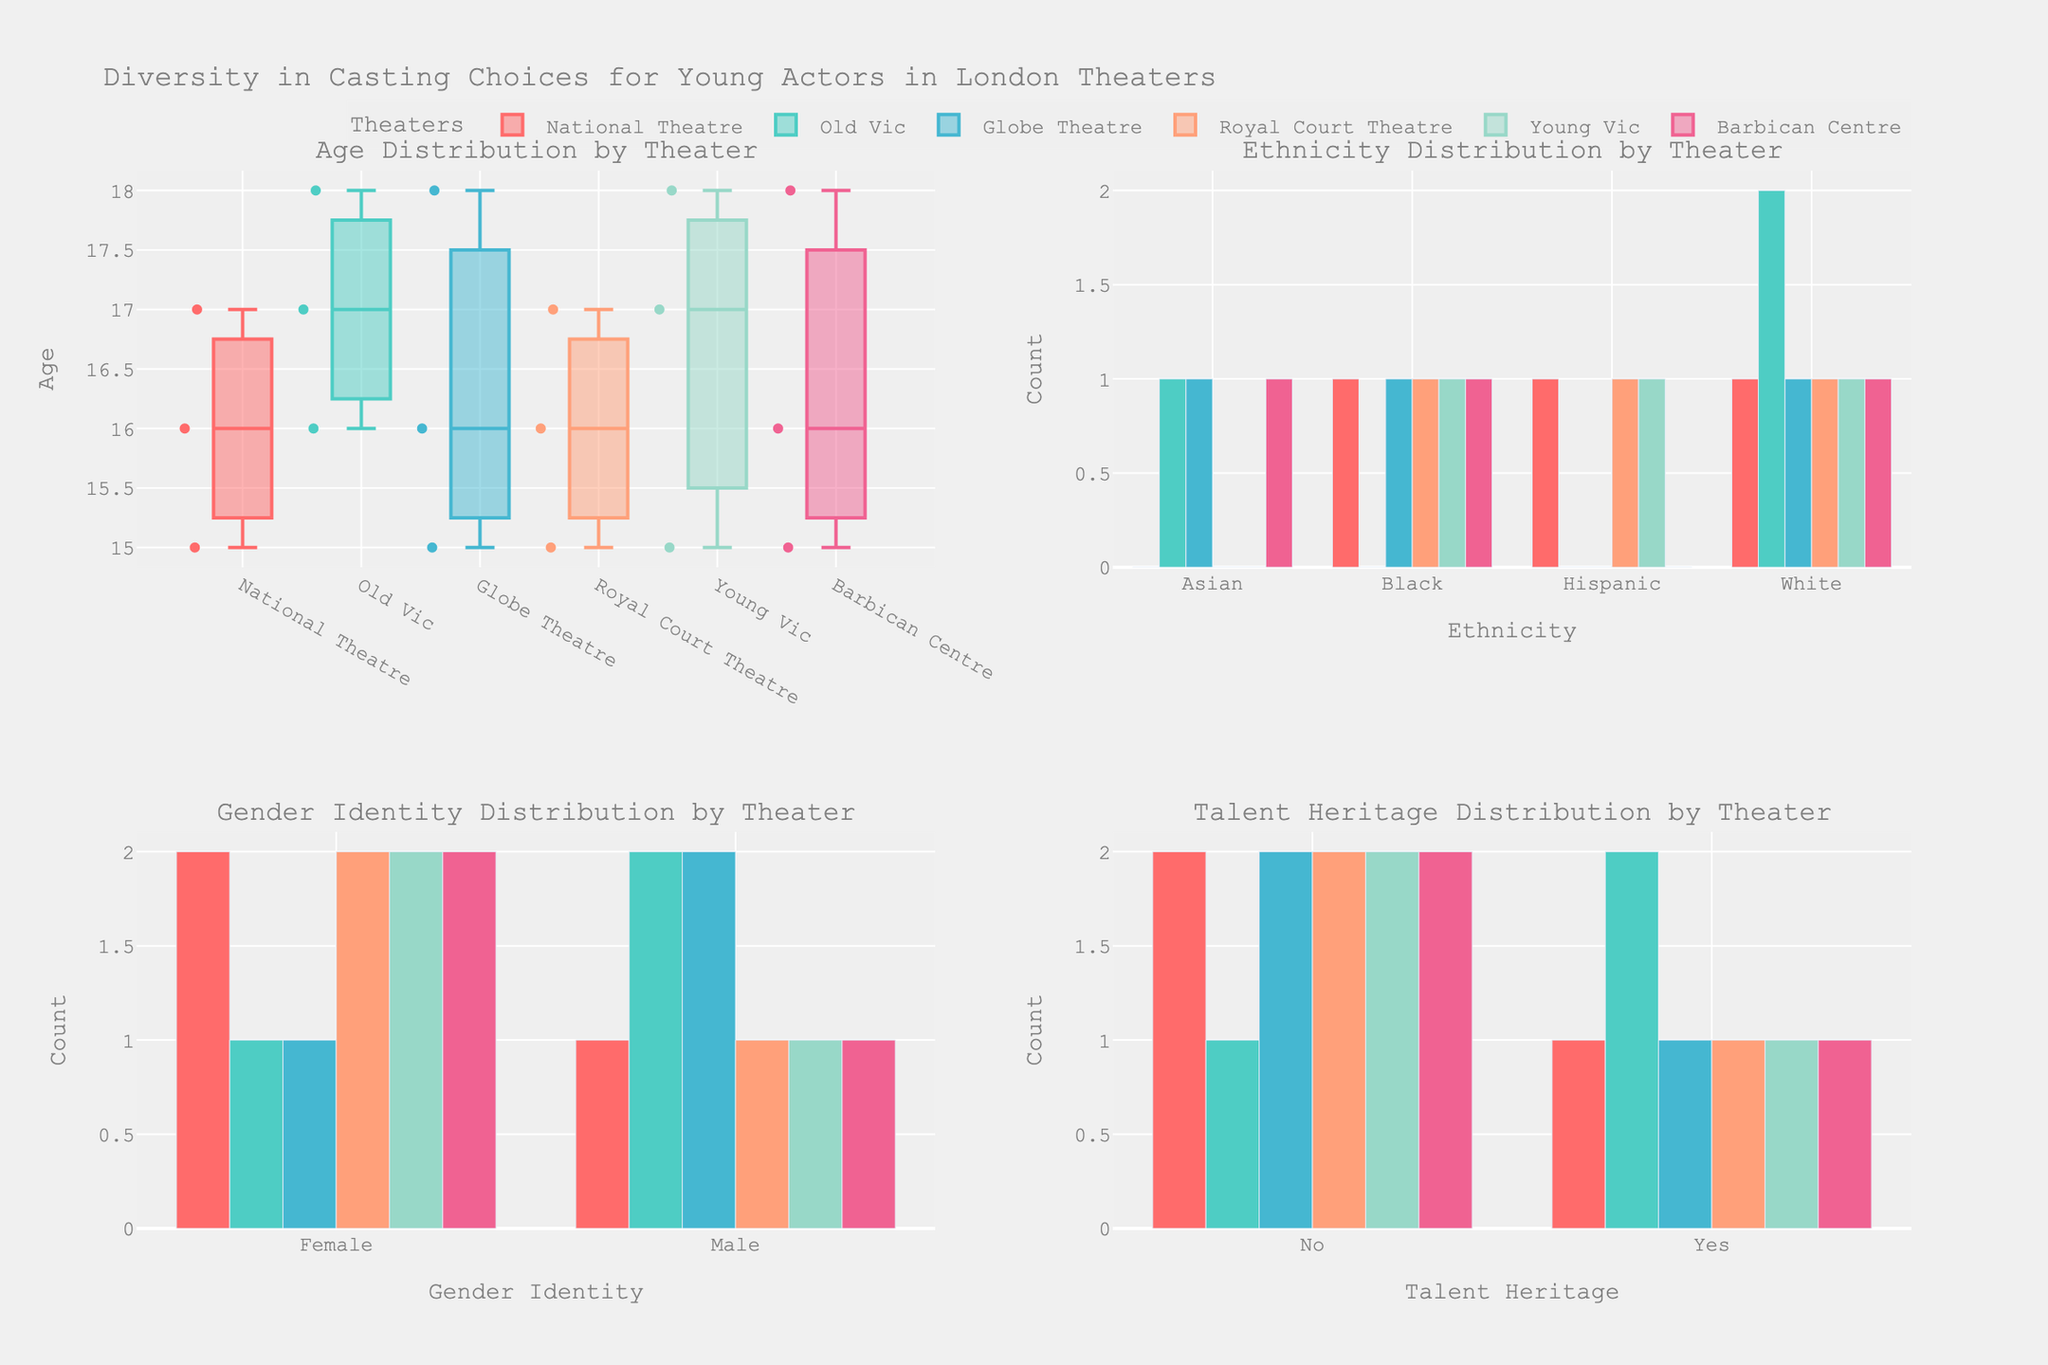What theaters show the highest and lowest age ranges for young actors? By referring to the "Age Distribution by Theater" subplot, the National Theatre and Old Vic showcase higher age ranges from 15 to 18, while Globe Theatre shows the lowest range starting at a younger age of 15 to the oldest age of 18.
Answer: National Theatre and Old Vic (highest), Globe Theatre (lowest) Which theater has the most diverse ethnic composition among young actors? Refer to the "Ethnicity Distribution by Theater" subplot; diversity is quantified by the number of different ethnic groups present. The National Theatre and Old Vic appear the most diverse, displaying multiple bar segments, indicating the presence of several ethnic groups.
Answer: National Theatre and Old Vic What is the most common gender identity represented across the theaters? Look at the "Gender Identity Distribution by Theater" subplot; sum the counts of male and female identities. The cumulative frequency can be visually assessed. Female appears to be more frequently represented.
Answer: Female How does the distribution of actors with and without talent heritage compare in the Globe Theatre? Check the "Talent Heritage Distribution by Theater" subplot, specifically at the Globe Theatre. Counting the bars, there are equal numbers of individuals with and without talent heritage.
Answer: Equal Across all theaters, which ethnicity has the highest representation? Look at the "Ethnicity Distribution by Theater" subplot, summing up the heights of each bar segment per ethnicity. The visual comparison shows that White ethnicity has the highest representation across theaters.
Answer: White What range does the median age of actors lie in each theater? Refer to the "Age Distribution by Theater" subplot, observing the central line within each box plot, representing the median age. Most theaters have a median falling around 16 or 17 years.
Answer: 16-17 years across most theaters Which theater has the highest concentration of actors with talent heritage? Look at the "Talent Heritage Distribution by Theater" subplot, comparing heights. National Theatre has the tallest bar for actors with talent heritage.
Answer: National Theatre What are the counts of male actors in the Young Vic? Refer to the "Gender Identity Distribution by Theater" subplot, look at the Young Vic section, and count the height of the Male bar.
Answer: 1 How does the age distribution in Royal Court Theatre compare to Old Vic? Refer to the "Age Distribution by Theater" subplot, compare the spread and median lines of the two box plots for Royal Court Theatre and Old Vic. Both have similar medians, but Royal Court Theatre shows more variability.
Answer: Similar medians, more variability in Royal Court Theatre List the number of Asian actors in the Old Vic and Barbican Centre. Reference the "Ethnicity Distribution by Theater" subplot. Count the heights of the 'Asian' bars for Old Vic and Barbican Centre. The heights indicate Old Vic has 1 and Barbican Centre has 0.
Answer: Old Vic: 1, Barbican Centre: 0 